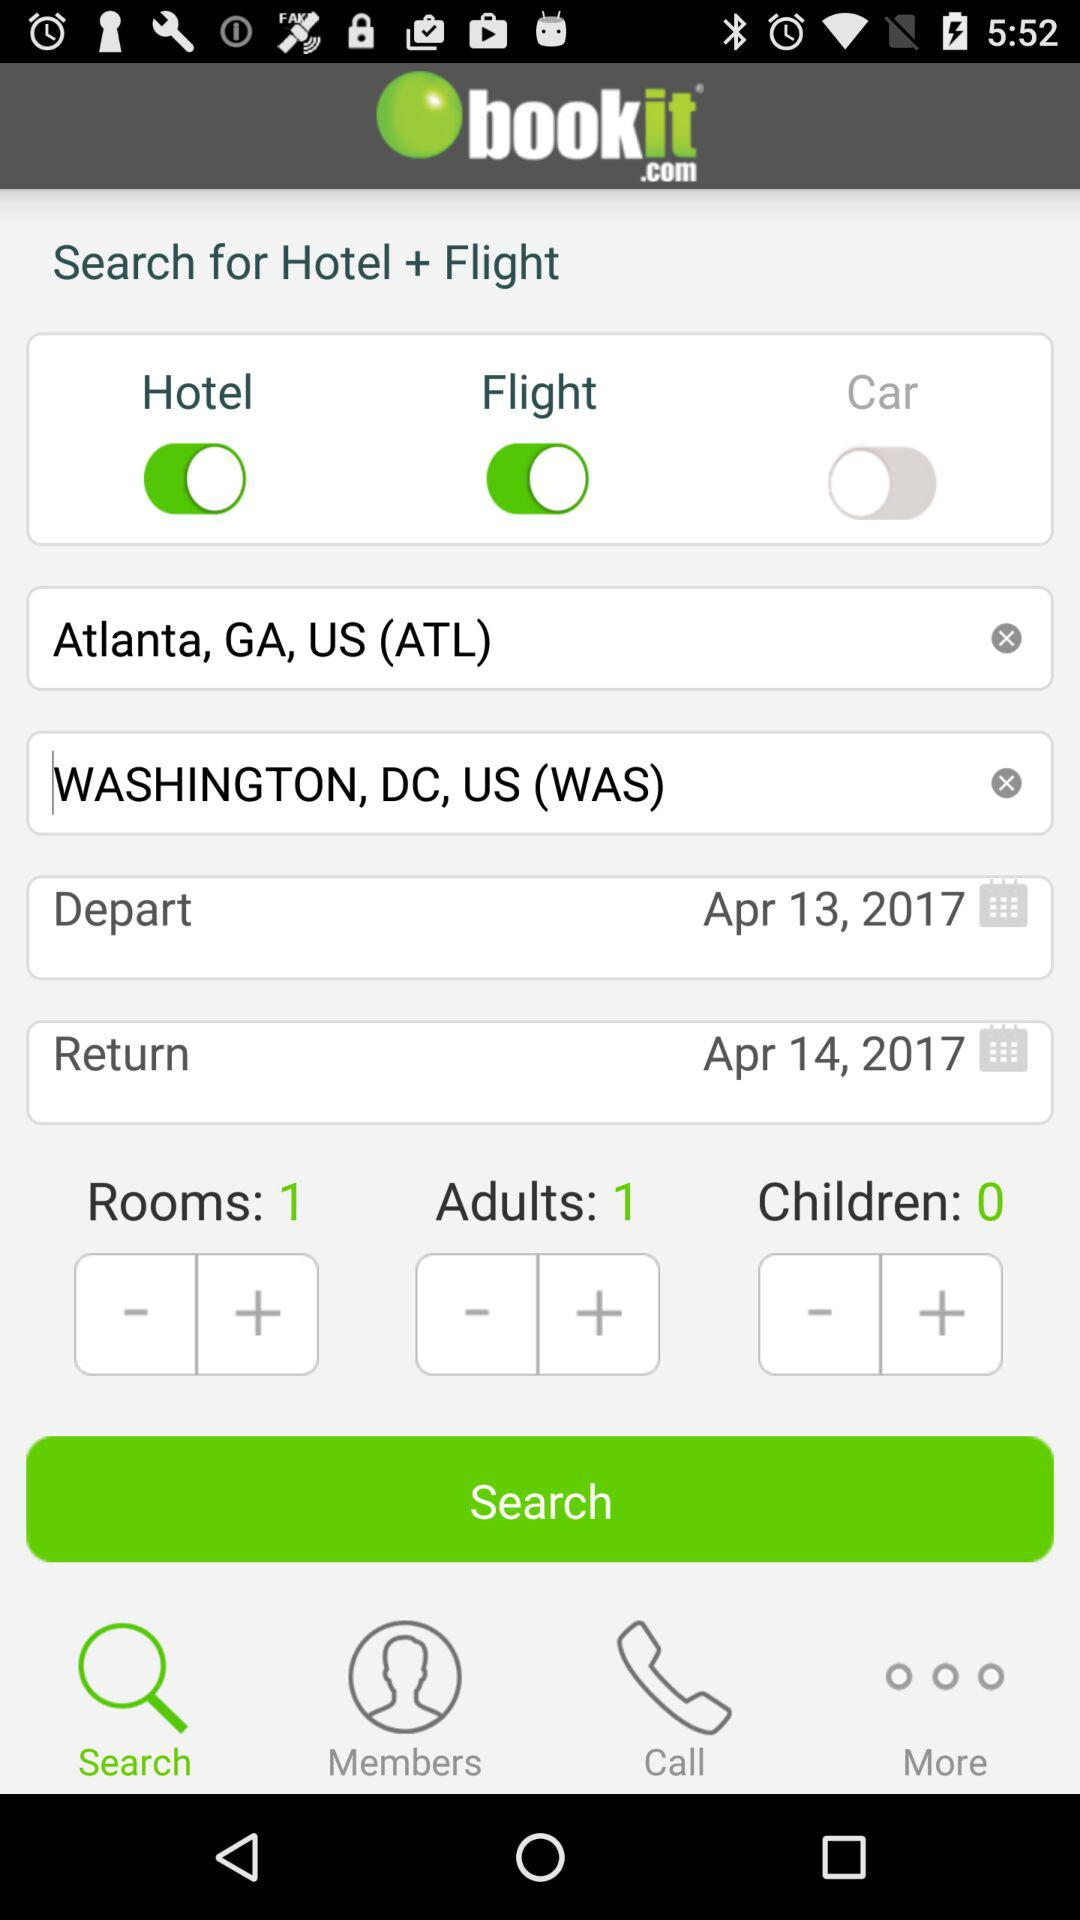For how many rooms is the person searching? The person is searching for 1 room. 